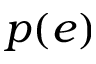<formula> <loc_0><loc_0><loc_500><loc_500>p ( e )</formula> 